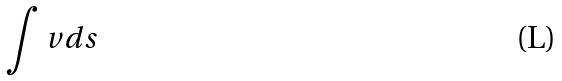<formula> <loc_0><loc_0><loc_500><loc_500>\int v d s</formula> 